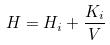<formula> <loc_0><loc_0><loc_500><loc_500>H = H _ { i } + \frac { K _ { i } } { V }</formula> 